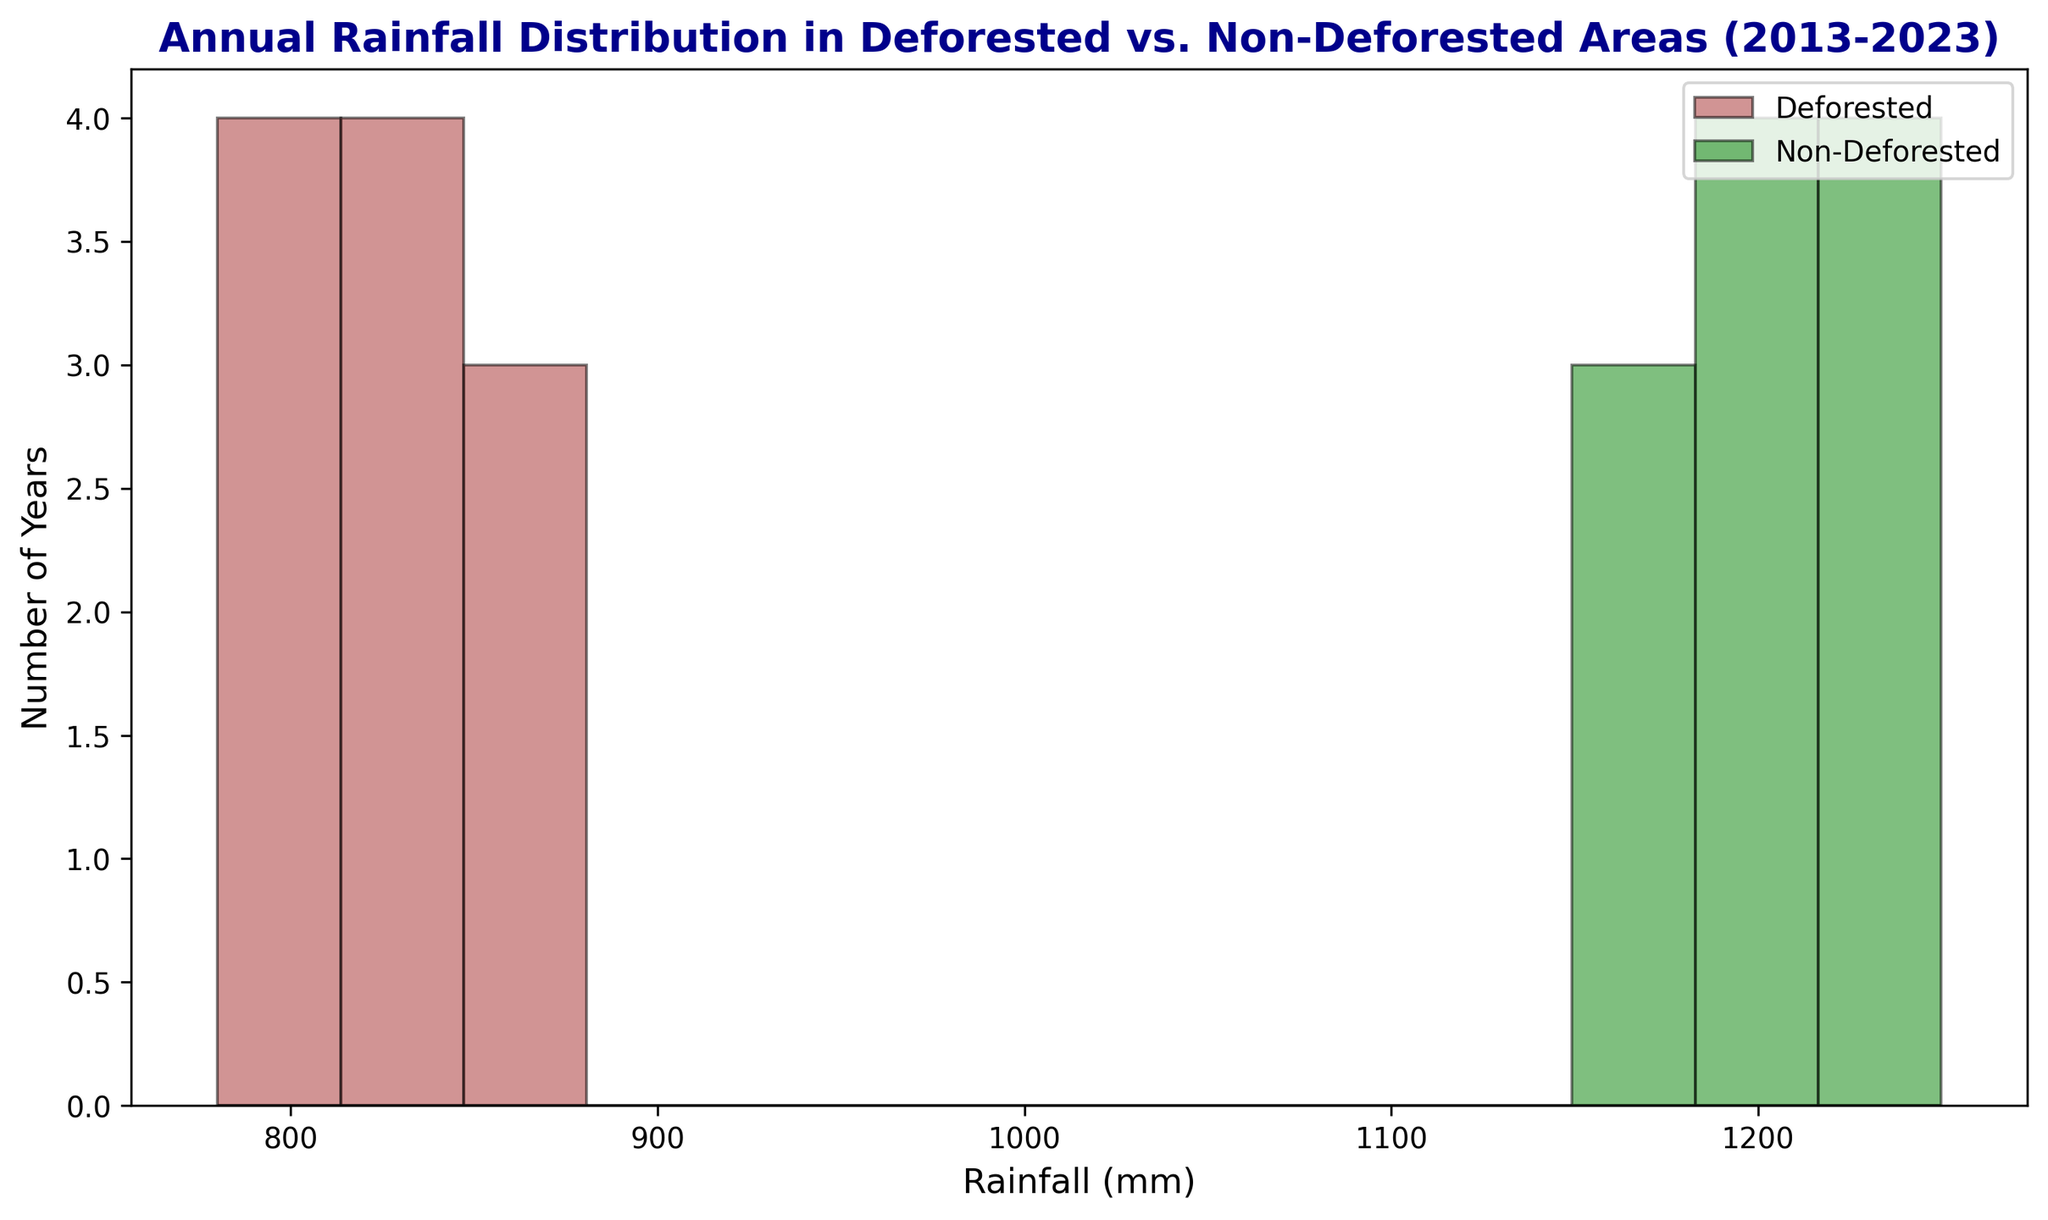Which type of area has the broader distribution of annual rainfall values? Look at the spread of the histogram bars. The bars for non-deforested areas range from 1150 mm to 1250 mm, while for deforested areas, they range from 780 mm to 870 mm. Non-deforested areas cover a 100 mm range, and deforested areas cover a 90 mm range. Non-deforested areas have a broader distribution by a small margin.
Answer: Non-deforested areas In which type of area do we see more variability in rainfall across the decade? Higher variability would be found in the area with a wider range of rainfall values and less consistency in the height of the bars. Non-deforested areas show more unique variability in values between 1150 mm to 1250 mm, compared to deforested areas' range of 780 mm to 870 mm.
Answer: Non-deforested areas How many years recorded annual rainfall between 800 mm and 820 mm in deforested areas? Examine the histogram bars for deforested areas within the range of 800 mm to 820 mm. There are two bars representing these years: 2014 (780 mm) and 2013 (850 mm), summing up to 2.
Answer: 2 years What is the average annual rainfall in non-deforested areas? Add up all the rainfall values for non-deforested areas (1200 + 1150 + 1180 + 1220 + 1250 + 1190 + 1210 + 1240 + 1170 + 1195 + 1235) and divide by the number of years (11). The total is 14340 mm, so the average is 14340 / 11 = 1303.64 mm.
Answer: 1303.64 mm 